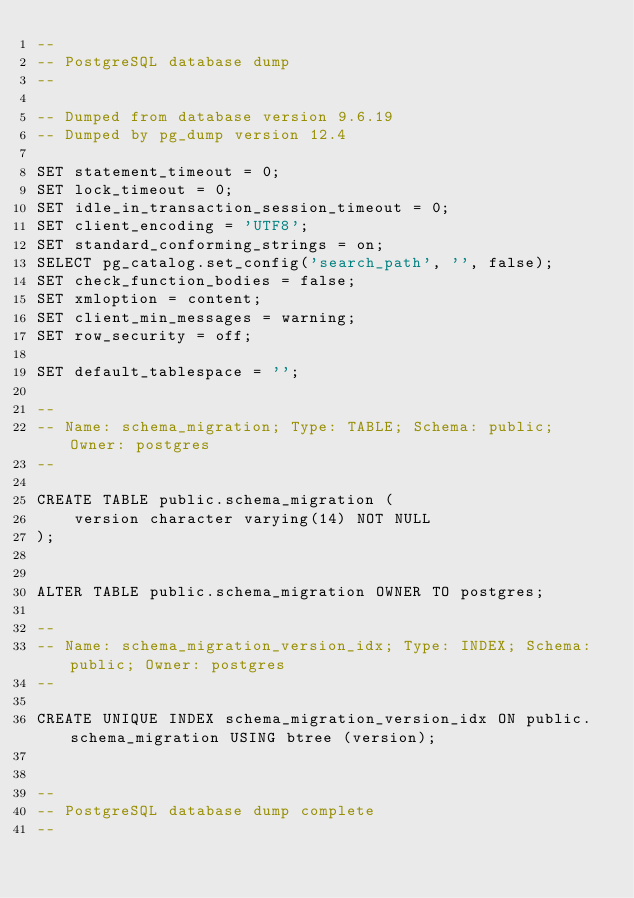Convert code to text. <code><loc_0><loc_0><loc_500><loc_500><_SQL_>--
-- PostgreSQL database dump
--

-- Dumped from database version 9.6.19
-- Dumped by pg_dump version 12.4

SET statement_timeout = 0;
SET lock_timeout = 0;
SET idle_in_transaction_session_timeout = 0;
SET client_encoding = 'UTF8';
SET standard_conforming_strings = on;
SELECT pg_catalog.set_config('search_path', '', false);
SET check_function_bodies = false;
SET xmloption = content;
SET client_min_messages = warning;
SET row_security = off;

SET default_tablespace = '';

--
-- Name: schema_migration; Type: TABLE; Schema: public; Owner: postgres
--

CREATE TABLE public.schema_migration (
    version character varying(14) NOT NULL
);


ALTER TABLE public.schema_migration OWNER TO postgres;

--
-- Name: schema_migration_version_idx; Type: INDEX; Schema: public; Owner: postgres
--

CREATE UNIQUE INDEX schema_migration_version_idx ON public.schema_migration USING btree (version);


--
-- PostgreSQL database dump complete
--

</code> 